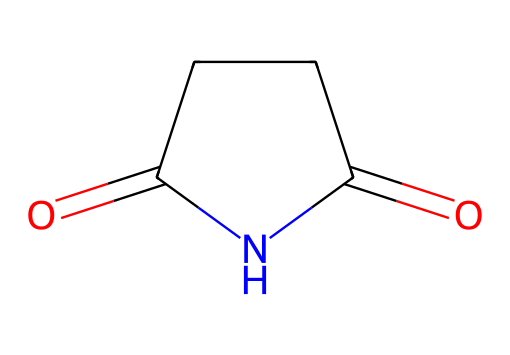How many carbon atoms are present in succinimide? The SMILES representation indicates the molecule has four carbon atoms in total, which can be counted from the linear structure.
Answer: four What functional groups are present in succinimide? The SMILES representation shows one amide (due to the nitrogen and carbonyl) and two carbonyl groups (C=O), categorizing it primarily as an imide.
Answer: amide, carbonyl How many nitrogen atoms are there in succinimide? The SMILES representation has one nitrogen atom, which is indicated by the "N" in the structure.
Answer: one What is the hybridization of the nitrogen atom in succinimide? The nitrogen in succinimide is bonded to two carbon atoms and has a lone pair; therefore, it is sp2 hybridized, which typically occurs in amides and imides.
Answer: sp2 What type of chemical compound is succinimide? Succinimide is classified as an imide, as it contains a cyclic structure with two carbonyl groups and one nitrogen atom in the ring.
Answer: imide What is the degree of unsaturation in succinimide? The formula for calculating the degree of unsaturation is (2C + 2 + N - H - X)/2. Plugging in the values (4 carbons, 1 nitrogen): (2(4) + 2 + 1 - 0)/2 = 5. This indicates there are 5 degrees of unsaturation, which corresponds with the ring and multiple bonds.
Answer: 5 In what types of reactions can succinimide participate? Succinimide can take part in nucleophilic substitution and acylation reactions due to the electrophilic character of the carbonyl groups and the presence of the nitrogen atom.
Answer: nucleophilic substitution, acylation 